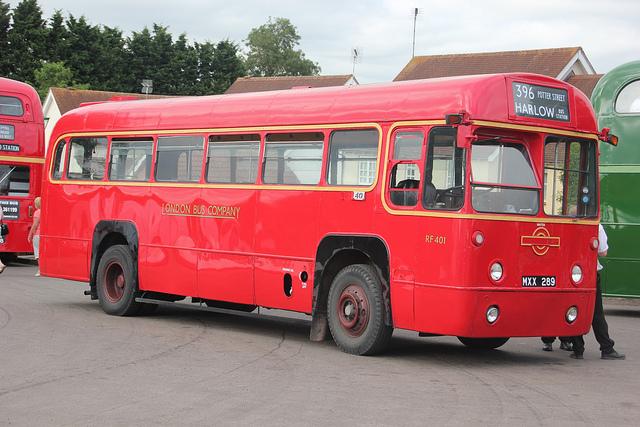Are there people standing behind the bus?
Concise answer only. Yes. Is this bus located in France?
Short answer required. No. Is the bus double-decker?
Keep it brief. No. What is the color of the bus?
Answer briefly. Red. What color is the bus?
Write a very short answer. Red. 